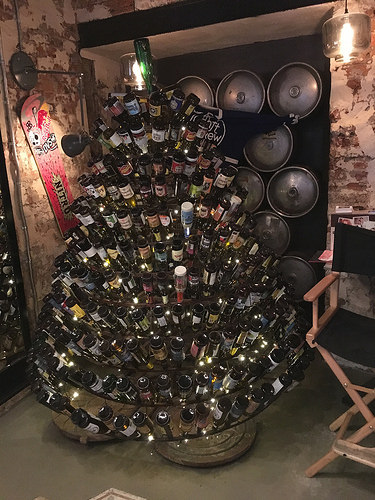<image>
Is the snowboard on the wall? Yes. Looking at the image, I can see the snowboard is positioned on top of the wall, with the wall providing support. 